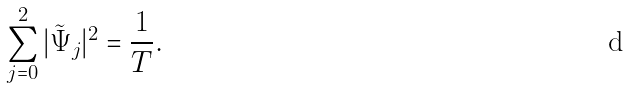<formula> <loc_0><loc_0><loc_500><loc_500>\sum _ { j = 0 } ^ { 2 } | \tilde { \Psi } _ { j } | ^ { 2 } = \frac { 1 } { T } .</formula> 